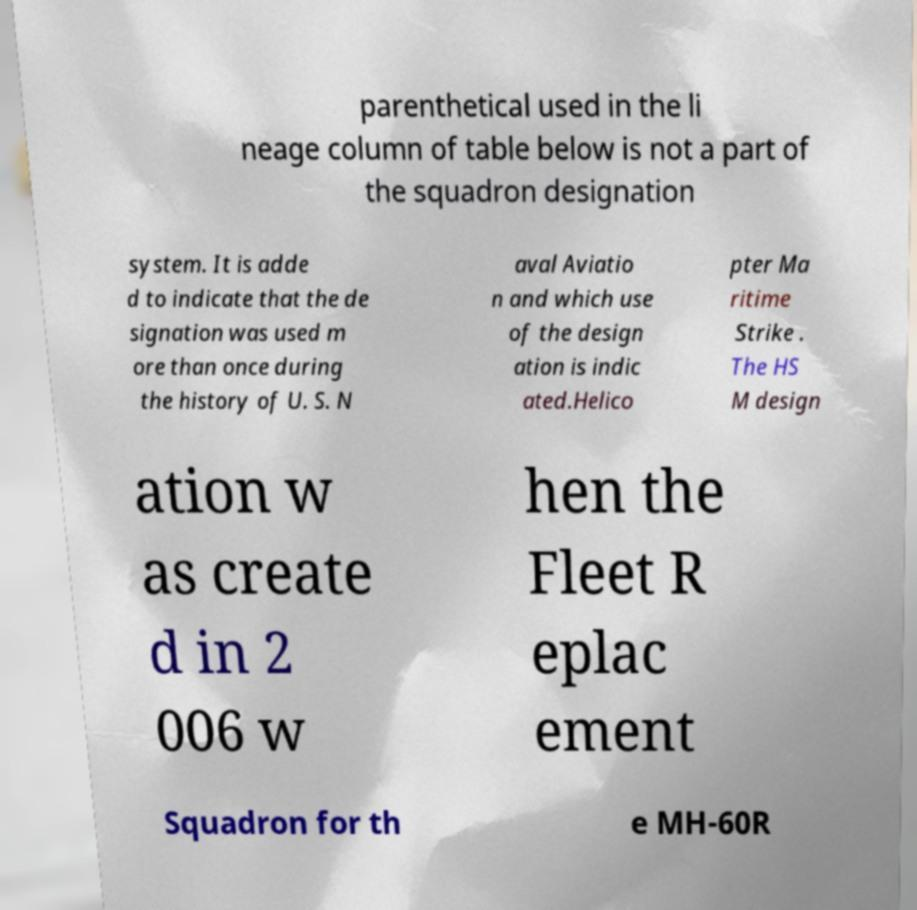Can you read and provide the text displayed in the image?This photo seems to have some interesting text. Can you extract and type it out for me? parenthetical used in the li neage column of table below is not a part of the squadron designation system. It is adde d to indicate that the de signation was used m ore than once during the history of U. S. N aval Aviatio n and which use of the design ation is indic ated.Helico pter Ma ritime Strike . The HS M design ation w as create d in 2 006 w hen the Fleet R eplac ement Squadron for th e MH-60R 